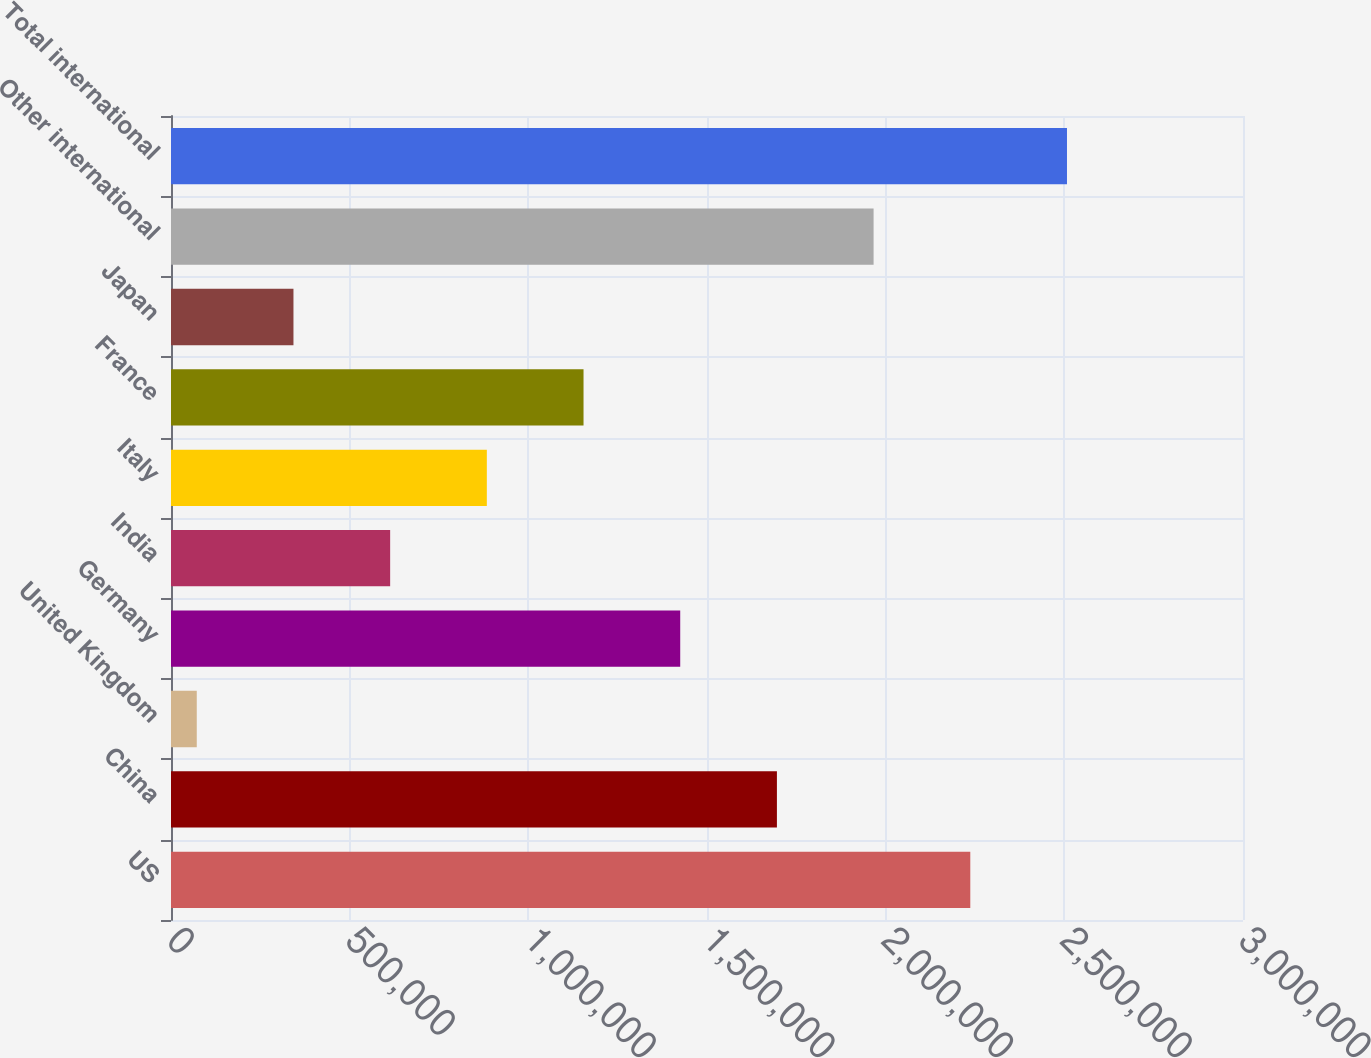Convert chart. <chart><loc_0><loc_0><loc_500><loc_500><bar_chart><fcel>US<fcel>China<fcel>United Kingdom<fcel>Germany<fcel>India<fcel>Italy<fcel>France<fcel>Japan<fcel>Other international<fcel>Total international<nl><fcel>2.23682e+06<fcel>1.69565e+06<fcel>72124<fcel>1.42506e+06<fcel>613298<fcel>883886<fcel>1.15447e+06<fcel>342711<fcel>1.96623e+06<fcel>2.50741e+06<nl></chart> 